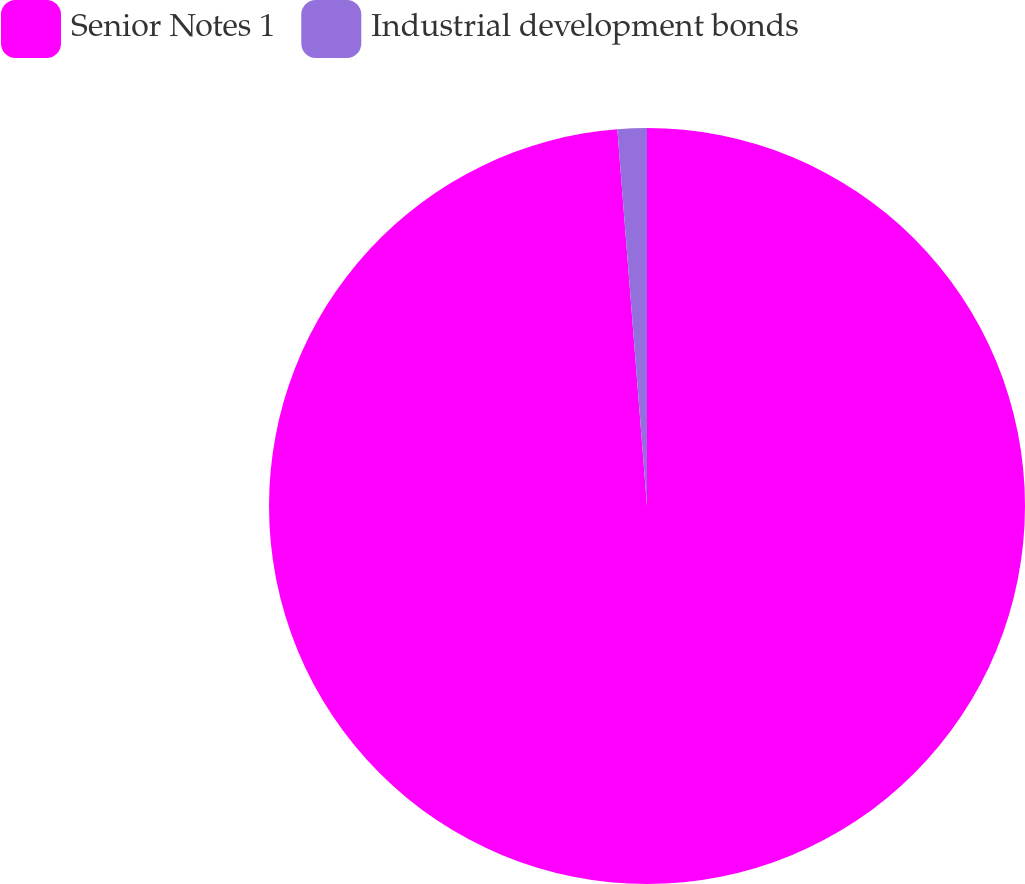<chart> <loc_0><loc_0><loc_500><loc_500><pie_chart><fcel>Senior Notes 1<fcel>Industrial development bonds<nl><fcel>98.75%<fcel>1.25%<nl></chart> 